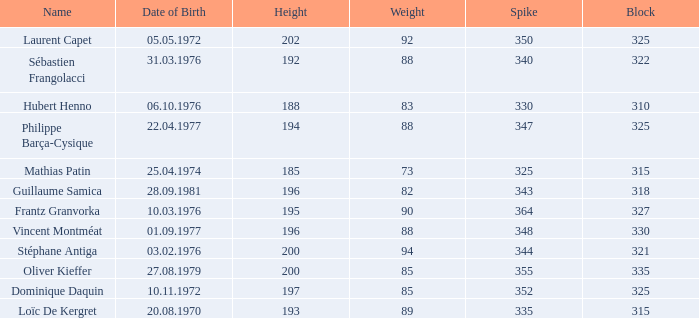How many spikes have 28.09.1981 as the date of birth, with a block greater than 318? None. Write the full table. {'header': ['Name', 'Date of Birth', 'Height', 'Weight', 'Spike', 'Block'], 'rows': [['Laurent Capet', '05.05.1972', '202', '92', '350', '325'], ['Sébastien Frangolacci', '31.03.1976', '192', '88', '340', '322'], ['Hubert Henno', '06.10.1976', '188', '83', '330', '310'], ['Philippe Barça-Cysique', '22.04.1977', '194', '88', '347', '325'], ['Mathias Patin', '25.04.1974', '185', '73', '325', '315'], ['Guillaume Samica', '28.09.1981', '196', '82', '343', '318'], ['Frantz Granvorka', '10.03.1976', '195', '90', '364', '327'], ['Vincent Montméat', '01.09.1977', '196', '88', '348', '330'], ['Stéphane Antiga', '03.02.1976', '200', '94', '344', '321'], ['Oliver Kieffer', '27.08.1979', '200', '85', '355', '335'], ['Dominique Daquin', '10.11.1972', '197', '85', '352', '325'], ['Loïc De Kergret', '20.08.1970', '193', '89', '335', '315']]} 